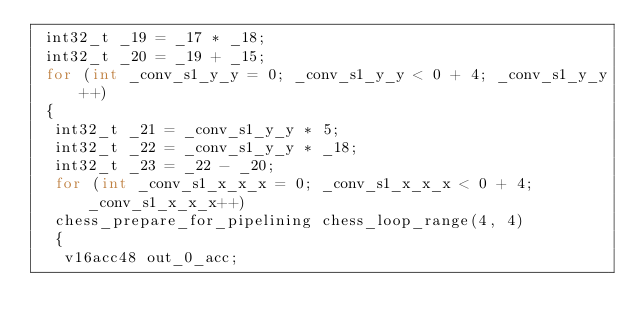<code> <loc_0><loc_0><loc_500><loc_500><_C++_> int32_t _19 = _17 * _18;
 int32_t _20 = _19 + _15;
 for (int _conv_s1_y_y = 0; _conv_s1_y_y < 0 + 4; _conv_s1_y_y++)
 {
  int32_t _21 = _conv_s1_y_y * 5;
  int32_t _22 = _conv_s1_y_y * _18;
  int32_t _23 = _22 - _20;
  for (int _conv_s1_x_x_x = 0; _conv_s1_x_x_x < 0 + 4; _conv_s1_x_x_x++)
  chess_prepare_for_pipelining chess_loop_range(4, 4)
  {
   v16acc48 out_0_acc;</code> 